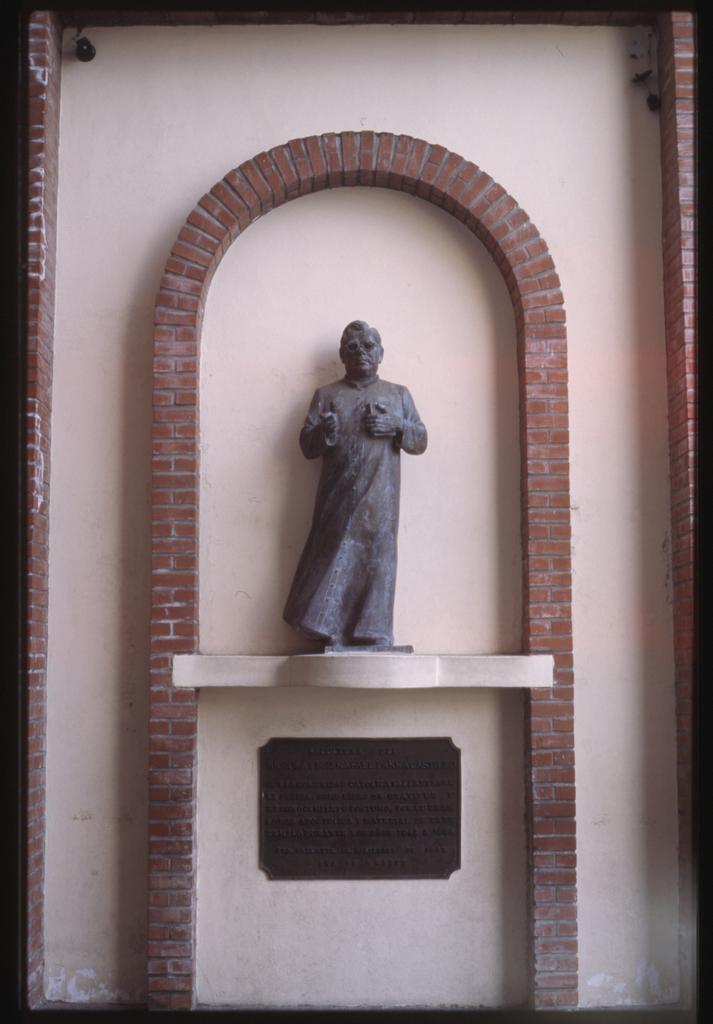Can you describe this image briefly? In this image I can see a statue of a person on a marble. I can see a board on the wall below the marble. I can see the brick design around the statue on the wall. 